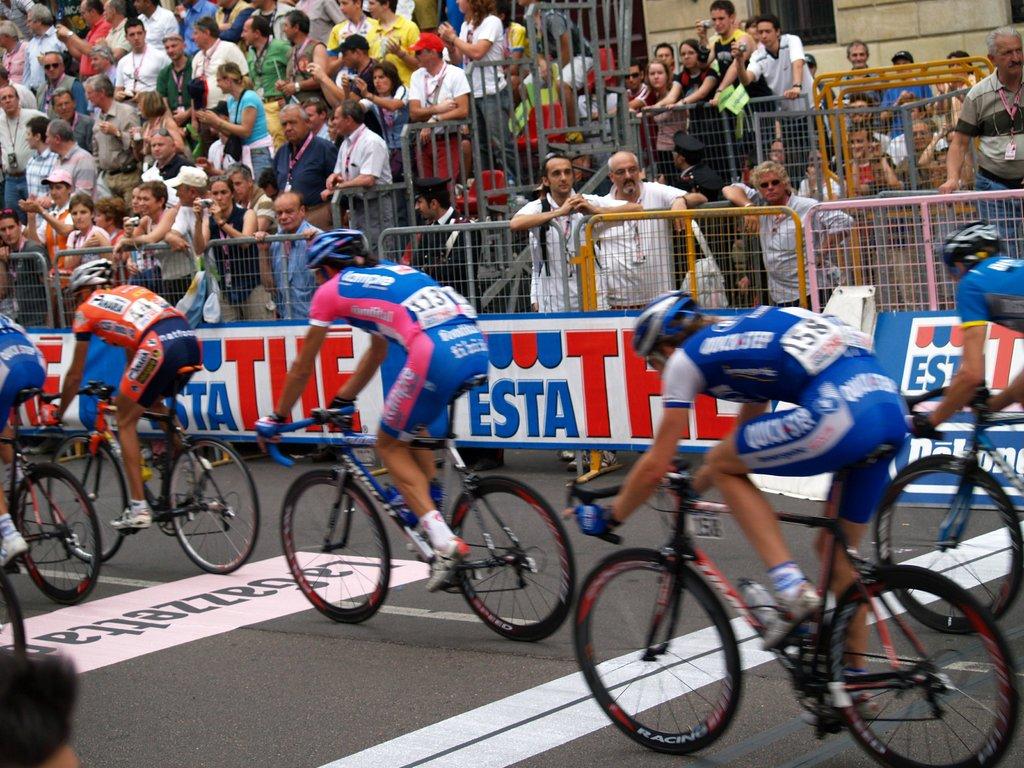Who is sponsoring the race?
Ensure brevity in your answer.  Esta. What number is the racer in the rear?
Give a very brief answer. 158. 